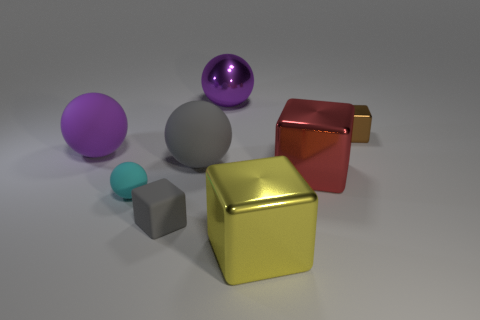What textures do the objects in this image have? The objects exhibit a variety of textures. The large gold cube has a shiny, reflective surface similar to metal, while the red cube next to it shares that reflective quality. The gray cube by contrast has a smoother, almost satin-like texture. The cyan sphere has a matte finish and the violet sphere seems glossy, yet less reflective than the metallic objects. 